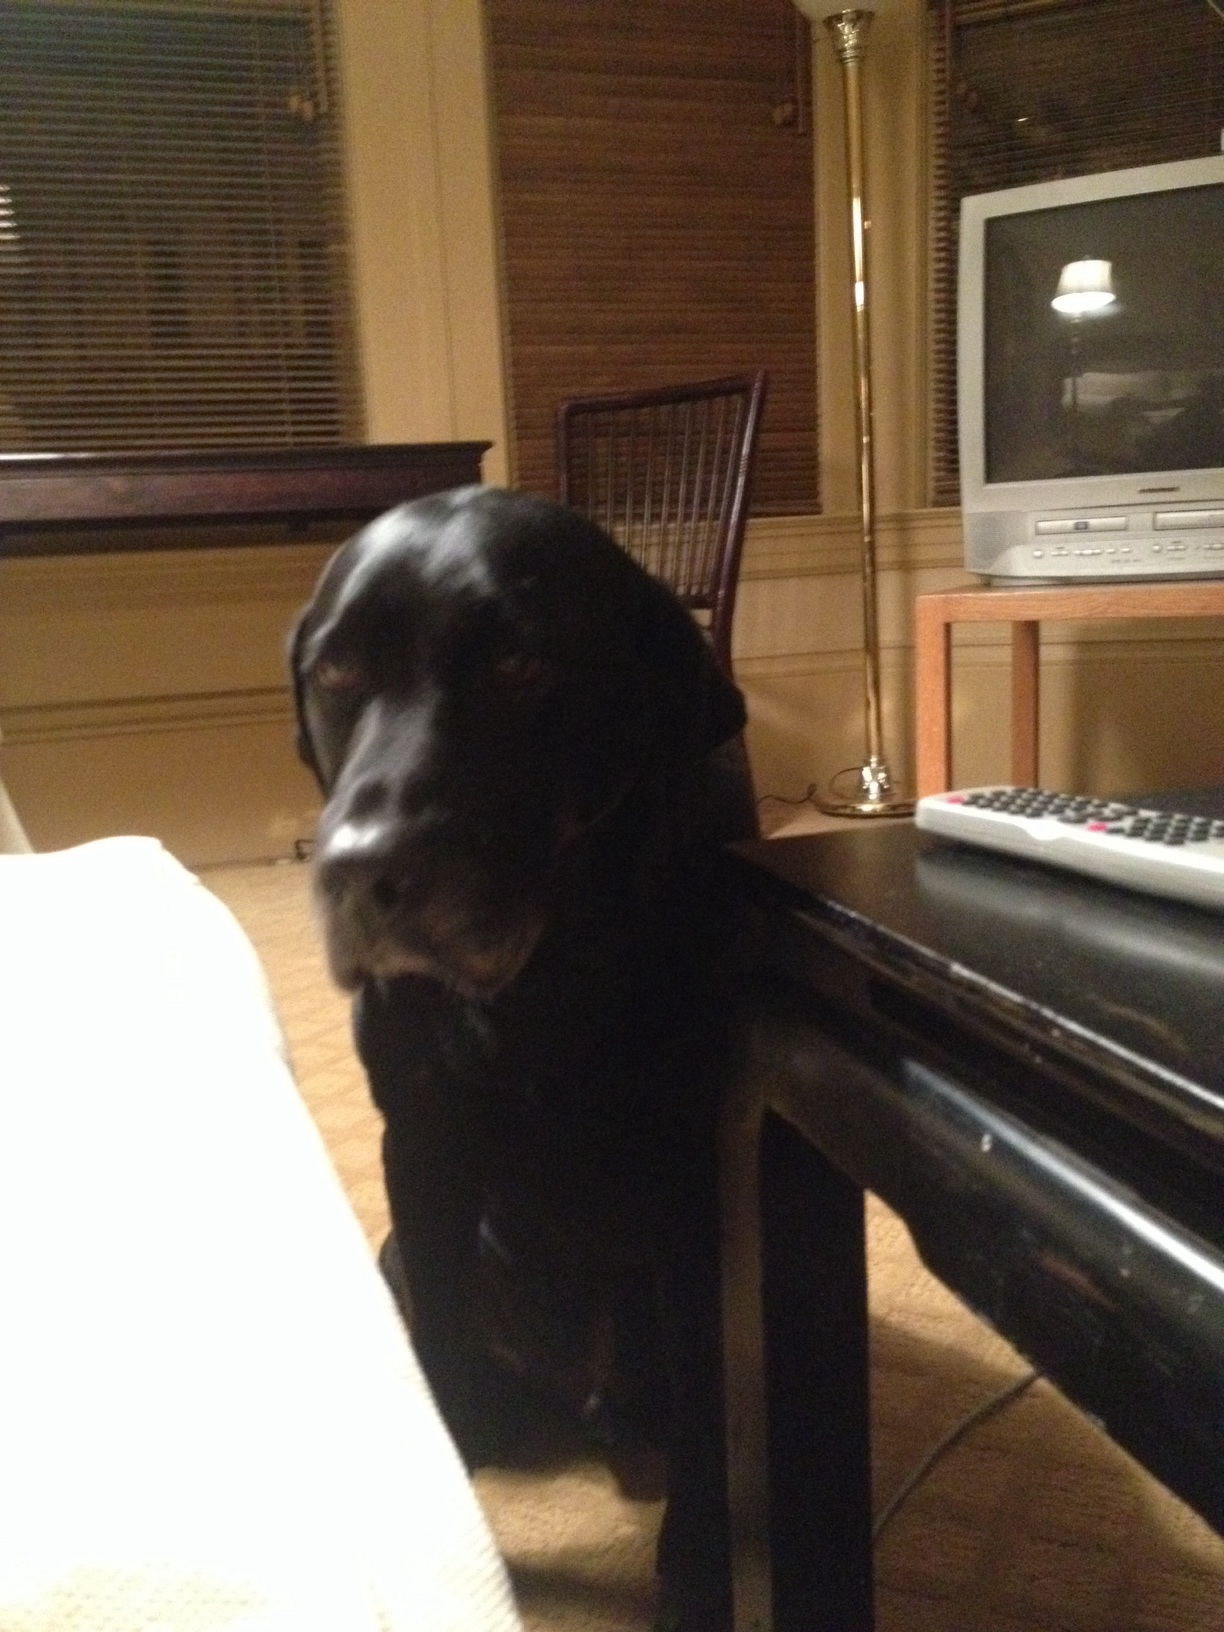What color is the dog in the picture? The dog in the picture is black, with a shiny coat that reflects some light, giving glimpses of a slightly lighter shade in certain areas, particularly around its snout and ears. 